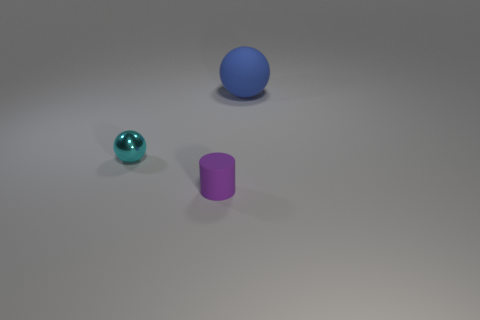Is the number of blue rubber objects that are behind the small matte thing less than the number of small cyan metal spheres in front of the tiny cyan object?
Make the answer very short. No. What number of other things are made of the same material as the large blue ball?
Your answer should be compact. 1. There is a purple thing that is the same size as the cyan ball; what is its material?
Provide a succinct answer. Rubber. Is the number of small cylinders behind the small matte thing less than the number of large green things?
Offer a very short reply. No. What is the shape of the matte thing that is behind the ball that is left of the rubber thing that is behind the small purple thing?
Provide a succinct answer. Sphere. How big is the sphere behind the small cyan ball?
Your response must be concise. Large. There is a object that is the same size as the matte cylinder; what is its shape?
Keep it short and to the point. Sphere. What number of objects are small blue cylinders or cyan spheres to the left of the big blue object?
Your answer should be very brief. 1. How many small matte cylinders are in front of the ball that is in front of the thing that is behind the tiny metal thing?
Keep it short and to the point. 1. The tiny cylinder that is made of the same material as the large sphere is what color?
Ensure brevity in your answer.  Purple. 